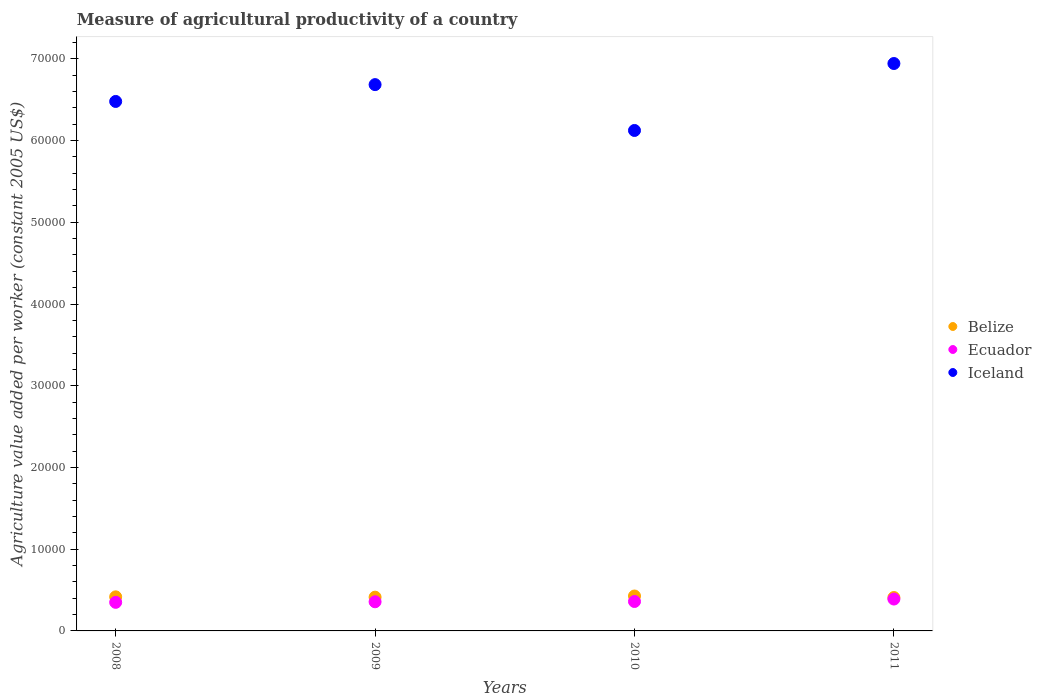Is the number of dotlines equal to the number of legend labels?
Offer a very short reply. Yes. What is the measure of agricultural productivity in Belize in 2008?
Your answer should be compact. 4170.07. Across all years, what is the maximum measure of agricultural productivity in Ecuador?
Make the answer very short. 3900.13. Across all years, what is the minimum measure of agricultural productivity in Iceland?
Your answer should be very brief. 6.12e+04. What is the total measure of agricultural productivity in Ecuador in the graph?
Your response must be concise. 1.46e+04. What is the difference between the measure of agricultural productivity in Iceland in 2008 and that in 2011?
Your answer should be compact. -4641.22. What is the difference between the measure of agricultural productivity in Iceland in 2011 and the measure of agricultural productivity in Ecuador in 2008?
Your answer should be compact. 6.59e+04. What is the average measure of agricultural productivity in Iceland per year?
Offer a terse response. 6.56e+04. In the year 2009, what is the difference between the measure of agricultural productivity in Ecuador and measure of agricultural productivity in Belize?
Your response must be concise. -564.79. What is the ratio of the measure of agricultural productivity in Iceland in 2010 to that in 2011?
Keep it short and to the point. 0.88. Is the difference between the measure of agricultural productivity in Ecuador in 2008 and 2011 greater than the difference between the measure of agricultural productivity in Belize in 2008 and 2011?
Your answer should be compact. No. What is the difference between the highest and the second highest measure of agricultural productivity in Belize?
Offer a terse response. 101.9. What is the difference between the highest and the lowest measure of agricultural productivity in Iceland?
Your response must be concise. 8192.74. In how many years, is the measure of agricultural productivity in Belize greater than the average measure of agricultural productivity in Belize taken over all years?
Give a very brief answer. 2. Is the sum of the measure of agricultural productivity in Iceland in 2009 and 2010 greater than the maximum measure of agricultural productivity in Belize across all years?
Provide a short and direct response. Yes. Does the measure of agricultural productivity in Iceland monotonically increase over the years?
Make the answer very short. No. How many years are there in the graph?
Offer a very short reply. 4. What is the difference between two consecutive major ticks on the Y-axis?
Your answer should be compact. 10000. Does the graph contain grids?
Provide a short and direct response. No. Where does the legend appear in the graph?
Offer a very short reply. Center right. How many legend labels are there?
Make the answer very short. 3. How are the legend labels stacked?
Offer a terse response. Vertical. What is the title of the graph?
Provide a short and direct response. Measure of agricultural productivity of a country. What is the label or title of the X-axis?
Keep it short and to the point. Years. What is the label or title of the Y-axis?
Provide a short and direct response. Agriculture value added per worker (constant 2005 US$). What is the Agriculture value added per worker (constant 2005 US$) in Belize in 2008?
Your answer should be compact. 4170.07. What is the Agriculture value added per worker (constant 2005 US$) of Ecuador in 2008?
Your answer should be compact. 3497.62. What is the Agriculture value added per worker (constant 2005 US$) in Iceland in 2008?
Provide a succinct answer. 6.48e+04. What is the Agriculture value added per worker (constant 2005 US$) in Belize in 2009?
Ensure brevity in your answer.  4131.07. What is the Agriculture value added per worker (constant 2005 US$) of Ecuador in 2009?
Offer a terse response. 3566.28. What is the Agriculture value added per worker (constant 2005 US$) of Iceland in 2009?
Your answer should be very brief. 6.68e+04. What is the Agriculture value added per worker (constant 2005 US$) of Belize in 2010?
Offer a terse response. 4271.96. What is the Agriculture value added per worker (constant 2005 US$) in Ecuador in 2010?
Ensure brevity in your answer.  3601.42. What is the Agriculture value added per worker (constant 2005 US$) in Iceland in 2010?
Make the answer very short. 6.12e+04. What is the Agriculture value added per worker (constant 2005 US$) of Belize in 2011?
Your answer should be very brief. 4086.43. What is the Agriculture value added per worker (constant 2005 US$) in Ecuador in 2011?
Your answer should be compact. 3900.13. What is the Agriculture value added per worker (constant 2005 US$) of Iceland in 2011?
Offer a very short reply. 6.94e+04. Across all years, what is the maximum Agriculture value added per worker (constant 2005 US$) in Belize?
Your response must be concise. 4271.96. Across all years, what is the maximum Agriculture value added per worker (constant 2005 US$) of Ecuador?
Your response must be concise. 3900.13. Across all years, what is the maximum Agriculture value added per worker (constant 2005 US$) in Iceland?
Give a very brief answer. 6.94e+04. Across all years, what is the minimum Agriculture value added per worker (constant 2005 US$) in Belize?
Your answer should be compact. 4086.43. Across all years, what is the minimum Agriculture value added per worker (constant 2005 US$) in Ecuador?
Make the answer very short. 3497.62. Across all years, what is the minimum Agriculture value added per worker (constant 2005 US$) of Iceland?
Provide a short and direct response. 6.12e+04. What is the total Agriculture value added per worker (constant 2005 US$) in Belize in the graph?
Make the answer very short. 1.67e+04. What is the total Agriculture value added per worker (constant 2005 US$) in Ecuador in the graph?
Your answer should be very brief. 1.46e+04. What is the total Agriculture value added per worker (constant 2005 US$) in Iceland in the graph?
Make the answer very short. 2.62e+05. What is the difference between the Agriculture value added per worker (constant 2005 US$) of Belize in 2008 and that in 2009?
Give a very brief answer. 38.99. What is the difference between the Agriculture value added per worker (constant 2005 US$) in Ecuador in 2008 and that in 2009?
Make the answer very short. -68.66. What is the difference between the Agriculture value added per worker (constant 2005 US$) in Iceland in 2008 and that in 2009?
Ensure brevity in your answer.  -2059.07. What is the difference between the Agriculture value added per worker (constant 2005 US$) in Belize in 2008 and that in 2010?
Keep it short and to the point. -101.9. What is the difference between the Agriculture value added per worker (constant 2005 US$) in Ecuador in 2008 and that in 2010?
Ensure brevity in your answer.  -103.8. What is the difference between the Agriculture value added per worker (constant 2005 US$) of Iceland in 2008 and that in 2010?
Give a very brief answer. 3551.52. What is the difference between the Agriculture value added per worker (constant 2005 US$) of Belize in 2008 and that in 2011?
Your answer should be very brief. 83.63. What is the difference between the Agriculture value added per worker (constant 2005 US$) of Ecuador in 2008 and that in 2011?
Offer a very short reply. -402.5. What is the difference between the Agriculture value added per worker (constant 2005 US$) of Iceland in 2008 and that in 2011?
Your response must be concise. -4641.22. What is the difference between the Agriculture value added per worker (constant 2005 US$) of Belize in 2009 and that in 2010?
Your response must be concise. -140.89. What is the difference between the Agriculture value added per worker (constant 2005 US$) of Ecuador in 2009 and that in 2010?
Provide a short and direct response. -35.14. What is the difference between the Agriculture value added per worker (constant 2005 US$) in Iceland in 2009 and that in 2010?
Give a very brief answer. 5610.59. What is the difference between the Agriculture value added per worker (constant 2005 US$) of Belize in 2009 and that in 2011?
Your response must be concise. 44.64. What is the difference between the Agriculture value added per worker (constant 2005 US$) of Ecuador in 2009 and that in 2011?
Give a very brief answer. -333.84. What is the difference between the Agriculture value added per worker (constant 2005 US$) in Iceland in 2009 and that in 2011?
Give a very brief answer. -2582.15. What is the difference between the Agriculture value added per worker (constant 2005 US$) of Belize in 2010 and that in 2011?
Make the answer very short. 185.53. What is the difference between the Agriculture value added per worker (constant 2005 US$) of Ecuador in 2010 and that in 2011?
Ensure brevity in your answer.  -298.7. What is the difference between the Agriculture value added per worker (constant 2005 US$) in Iceland in 2010 and that in 2011?
Give a very brief answer. -8192.74. What is the difference between the Agriculture value added per worker (constant 2005 US$) of Belize in 2008 and the Agriculture value added per worker (constant 2005 US$) of Ecuador in 2009?
Give a very brief answer. 603.79. What is the difference between the Agriculture value added per worker (constant 2005 US$) in Belize in 2008 and the Agriculture value added per worker (constant 2005 US$) in Iceland in 2009?
Provide a succinct answer. -6.27e+04. What is the difference between the Agriculture value added per worker (constant 2005 US$) of Ecuador in 2008 and the Agriculture value added per worker (constant 2005 US$) of Iceland in 2009?
Provide a short and direct response. -6.33e+04. What is the difference between the Agriculture value added per worker (constant 2005 US$) of Belize in 2008 and the Agriculture value added per worker (constant 2005 US$) of Ecuador in 2010?
Your answer should be compact. 568.65. What is the difference between the Agriculture value added per worker (constant 2005 US$) in Belize in 2008 and the Agriculture value added per worker (constant 2005 US$) in Iceland in 2010?
Make the answer very short. -5.71e+04. What is the difference between the Agriculture value added per worker (constant 2005 US$) of Ecuador in 2008 and the Agriculture value added per worker (constant 2005 US$) of Iceland in 2010?
Provide a short and direct response. -5.77e+04. What is the difference between the Agriculture value added per worker (constant 2005 US$) in Belize in 2008 and the Agriculture value added per worker (constant 2005 US$) in Ecuador in 2011?
Offer a very short reply. 269.94. What is the difference between the Agriculture value added per worker (constant 2005 US$) of Belize in 2008 and the Agriculture value added per worker (constant 2005 US$) of Iceland in 2011?
Give a very brief answer. -6.53e+04. What is the difference between the Agriculture value added per worker (constant 2005 US$) of Ecuador in 2008 and the Agriculture value added per worker (constant 2005 US$) of Iceland in 2011?
Make the answer very short. -6.59e+04. What is the difference between the Agriculture value added per worker (constant 2005 US$) in Belize in 2009 and the Agriculture value added per worker (constant 2005 US$) in Ecuador in 2010?
Your answer should be very brief. 529.65. What is the difference between the Agriculture value added per worker (constant 2005 US$) in Belize in 2009 and the Agriculture value added per worker (constant 2005 US$) in Iceland in 2010?
Make the answer very short. -5.71e+04. What is the difference between the Agriculture value added per worker (constant 2005 US$) of Ecuador in 2009 and the Agriculture value added per worker (constant 2005 US$) of Iceland in 2010?
Offer a terse response. -5.77e+04. What is the difference between the Agriculture value added per worker (constant 2005 US$) of Belize in 2009 and the Agriculture value added per worker (constant 2005 US$) of Ecuador in 2011?
Offer a terse response. 230.95. What is the difference between the Agriculture value added per worker (constant 2005 US$) of Belize in 2009 and the Agriculture value added per worker (constant 2005 US$) of Iceland in 2011?
Keep it short and to the point. -6.53e+04. What is the difference between the Agriculture value added per worker (constant 2005 US$) in Ecuador in 2009 and the Agriculture value added per worker (constant 2005 US$) in Iceland in 2011?
Provide a short and direct response. -6.59e+04. What is the difference between the Agriculture value added per worker (constant 2005 US$) of Belize in 2010 and the Agriculture value added per worker (constant 2005 US$) of Ecuador in 2011?
Offer a terse response. 371.84. What is the difference between the Agriculture value added per worker (constant 2005 US$) in Belize in 2010 and the Agriculture value added per worker (constant 2005 US$) in Iceland in 2011?
Your answer should be compact. -6.52e+04. What is the difference between the Agriculture value added per worker (constant 2005 US$) in Ecuador in 2010 and the Agriculture value added per worker (constant 2005 US$) in Iceland in 2011?
Provide a short and direct response. -6.58e+04. What is the average Agriculture value added per worker (constant 2005 US$) in Belize per year?
Keep it short and to the point. 4164.89. What is the average Agriculture value added per worker (constant 2005 US$) in Ecuador per year?
Provide a short and direct response. 3641.36. What is the average Agriculture value added per worker (constant 2005 US$) in Iceland per year?
Keep it short and to the point. 6.56e+04. In the year 2008, what is the difference between the Agriculture value added per worker (constant 2005 US$) of Belize and Agriculture value added per worker (constant 2005 US$) of Ecuador?
Ensure brevity in your answer.  672.45. In the year 2008, what is the difference between the Agriculture value added per worker (constant 2005 US$) in Belize and Agriculture value added per worker (constant 2005 US$) in Iceland?
Make the answer very short. -6.06e+04. In the year 2008, what is the difference between the Agriculture value added per worker (constant 2005 US$) of Ecuador and Agriculture value added per worker (constant 2005 US$) of Iceland?
Provide a succinct answer. -6.13e+04. In the year 2009, what is the difference between the Agriculture value added per worker (constant 2005 US$) in Belize and Agriculture value added per worker (constant 2005 US$) in Ecuador?
Make the answer very short. 564.79. In the year 2009, what is the difference between the Agriculture value added per worker (constant 2005 US$) of Belize and Agriculture value added per worker (constant 2005 US$) of Iceland?
Offer a terse response. -6.27e+04. In the year 2009, what is the difference between the Agriculture value added per worker (constant 2005 US$) in Ecuador and Agriculture value added per worker (constant 2005 US$) in Iceland?
Give a very brief answer. -6.33e+04. In the year 2010, what is the difference between the Agriculture value added per worker (constant 2005 US$) in Belize and Agriculture value added per worker (constant 2005 US$) in Ecuador?
Keep it short and to the point. 670.54. In the year 2010, what is the difference between the Agriculture value added per worker (constant 2005 US$) in Belize and Agriculture value added per worker (constant 2005 US$) in Iceland?
Your response must be concise. -5.70e+04. In the year 2010, what is the difference between the Agriculture value added per worker (constant 2005 US$) of Ecuador and Agriculture value added per worker (constant 2005 US$) of Iceland?
Your answer should be compact. -5.76e+04. In the year 2011, what is the difference between the Agriculture value added per worker (constant 2005 US$) of Belize and Agriculture value added per worker (constant 2005 US$) of Ecuador?
Ensure brevity in your answer.  186.31. In the year 2011, what is the difference between the Agriculture value added per worker (constant 2005 US$) in Belize and Agriculture value added per worker (constant 2005 US$) in Iceland?
Provide a short and direct response. -6.53e+04. In the year 2011, what is the difference between the Agriculture value added per worker (constant 2005 US$) in Ecuador and Agriculture value added per worker (constant 2005 US$) in Iceland?
Offer a very short reply. -6.55e+04. What is the ratio of the Agriculture value added per worker (constant 2005 US$) in Belize in 2008 to that in 2009?
Your response must be concise. 1.01. What is the ratio of the Agriculture value added per worker (constant 2005 US$) of Ecuador in 2008 to that in 2009?
Offer a terse response. 0.98. What is the ratio of the Agriculture value added per worker (constant 2005 US$) in Iceland in 2008 to that in 2009?
Your answer should be compact. 0.97. What is the ratio of the Agriculture value added per worker (constant 2005 US$) of Belize in 2008 to that in 2010?
Give a very brief answer. 0.98. What is the ratio of the Agriculture value added per worker (constant 2005 US$) of Ecuador in 2008 to that in 2010?
Offer a very short reply. 0.97. What is the ratio of the Agriculture value added per worker (constant 2005 US$) in Iceland in 2008 to that in 2010?
Provide a short and direct response. 1.06. What is the ratio of the Agriculture value added per worker (constant 2005 US$) of Belize in 2008 to that in 2011?
Offer a very short reply. 1.02. What is the ratio of the Agriculture value added per worker (constant 2005 US$) in Ecuador in 2008 to that in 2011?
Provide a succinct answer. 0.9. What is the ratio of the Agriculture value added per worker (constant 2005 US$) of Iceland in 2008 to that in 2011?
Make the answer very short. 0.93. What is the ratio of the Agriculture value added per worker (constant 2005 US$) of Ecuador in 2009 to that in 2010?
Keep it short and to the point. 0.99. What is the ratio of the Agriculture value added per worker (constant 2005 US$) of Iceland in 2009 to that in 2010?
Give a very brief answer. 1.09. What is the ratio of the Agriculture value added per worker (constant 2005 US$) in Belize in 2009 to that in 2011?
Provide a short and direct response. 1.01. What is the ratio of the Agriculture value added per worker (constant 2005 US$) in Ecuador in 2009 to that in 2011?
Your answer should be very brief. 0.91. What is the ratio of the Agriculture value added per worker (constant 2005 US$) of Iceland in 2009 to that in 2011?
Offer a very short reply. 0.96. What is the ratio of the Agriculture value added per worker (constant 2005 US$) of Belize in 2010 to that in 2011?
Offer a very short reply. 1.05. What is the ratio of the Agriculture value added per worker (constant 2005 US$) of Ecuador in 2010 to that in 2011?
Your response must be concise. 0.92. What is the ratio of the Agriculture value added per worker (constant 2005 US$) in Iceland in 2010 to that in 2011?
Your answer should be very brief. 0.88. What is the difference between the highest and the second highest Agriculture value added per worker (constant 2005 US$) of Belize?
Give a very brief answer. 101.9. What is the difference between the highest and the second highest Agriculture value added per worker (constant 2005 US$) of Ecuador?
Offer a very short reply. 298.7. What is the difference between the highest and the second highest Agriculture value added per worker (constant 2005 US$) of Iceland?
Give a very brief answer. 2582.15. What is the difference between the highest and the lowest Agriculture value added per worker (constant 2005 US$) in Belize?
Make the answer very short. 185.53. What is the difference between the highest and the lowest Agriculture value added per worker (constant 2005 US$) in Ecuador?
Give a very brief answer. 402.5. What is the difference between the highest and the lowest Agriculture value added per worker (constant 2005 US$) in Iceland?
Ensure brevity in your answer.  8192.74. 